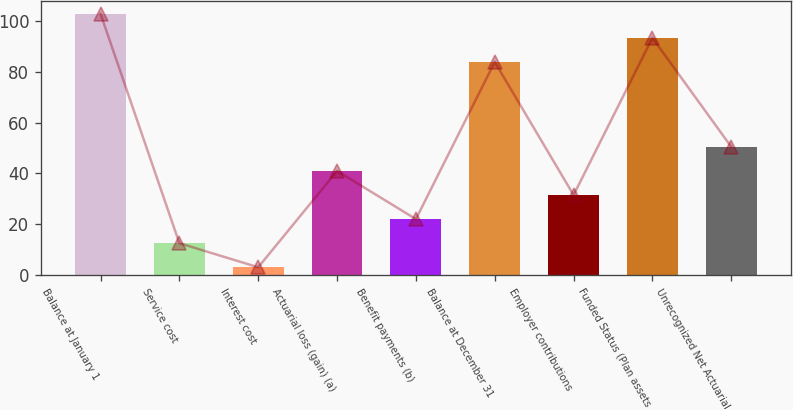<chart> <loc_0><loc_0><loc_500><loc_500><bar_chart><fcel>Balance at January 1<fcel>Service cost<fcel>Interest cost<fcel>Actuarial loss (gain) (a)<fcel>Benefit payments (b)<fcel>Balance at December 31<fcel>Employer contributions<fcel>Funded Status (Plan assets<fcel>Unrecognized Net Actuarial<nl><fcel>103<fcel>12.5<fcel>3<fcel>41<fcel>22<fcel>84<fcel>31.5<fcel>93.5<fcel>50.5<nl></chart> 